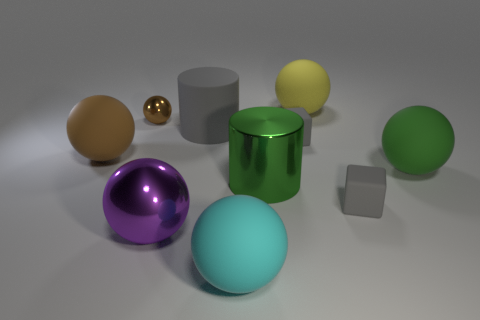Subtract all matte balls. How many balls are left? 2 Subtract all green balls. How many balls are left? 5 Subtract all cubes. How many objects are left? 8 Subtract 1 cylinders. How many cylinders are left? 1 Subtract all brown cubes. How many purple cylinders are left? 0 Add 6 cubes. How many cubes are left? 8 Add 7 cyan matte things. How many cyan matte things exist? 8 Subtract 2 brown spheres. How many objects are left? 8 Subtract all brown balls. Subtract all yellow blocks. How many balls are left? 4 Subtract all cyan rubber cubes. Subtract all metallic objects. How many objects are left? 7 